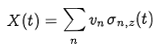<formula> <loc_0><loc_0><loc_500><loc_500>X ( t ) = \sum _ { n } v _ { n } \sigma _ { n , z } ( t )</formula> 